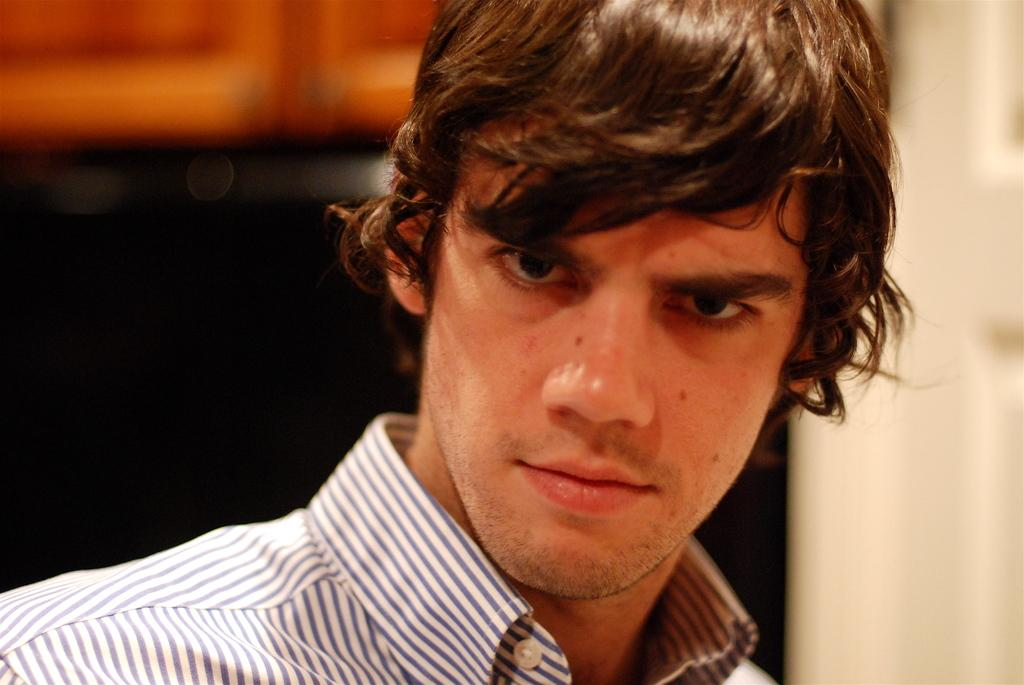What is present in the image? There is a person in the image. What is the person doing in the image? The person is focusing their eyes on something. What type of company can be seen operating in the harbor in the image? There is no company or harbor present in the image; it only features a person focusing their eyes on something. 